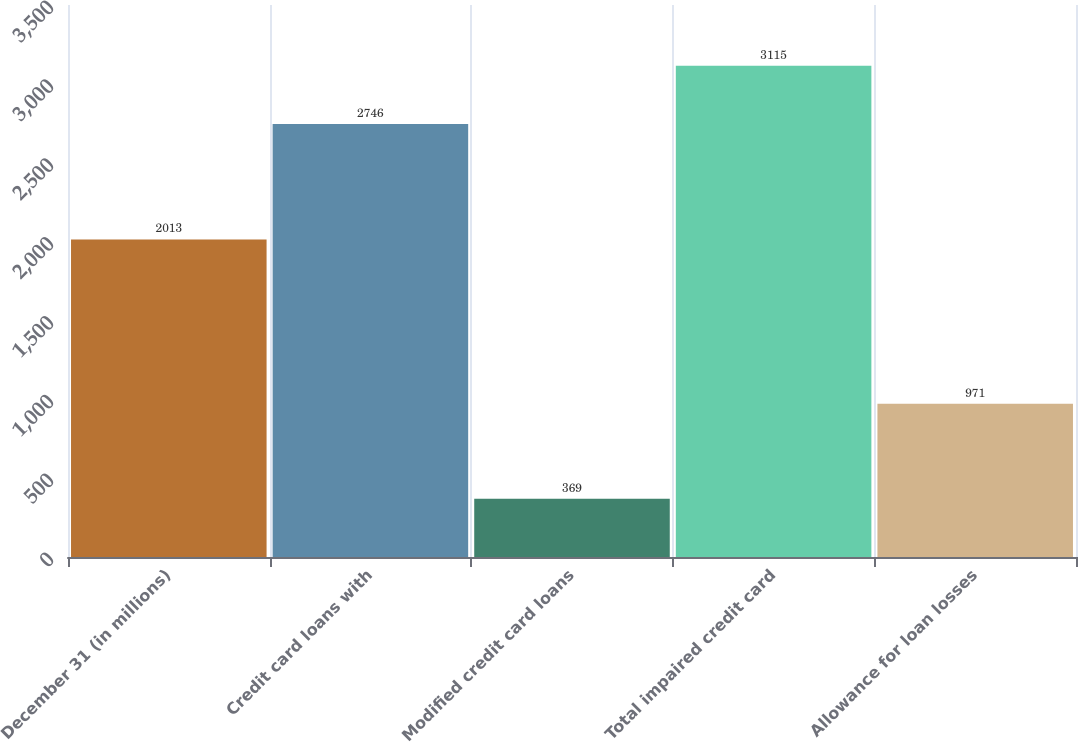<chart> <loc_0><loc_0><loc_500><loc_500><bar_chart><fcel>December 31 (in millions)<fcel>Credit card loans with<fcel>Modified credit card loans<fcel>Total impaired credit card<fcel>Allowance for loan losses<nl><fcel>2013<fcel>2746<fcel>369<fcel>3115<fcel>971<nl></chart> 